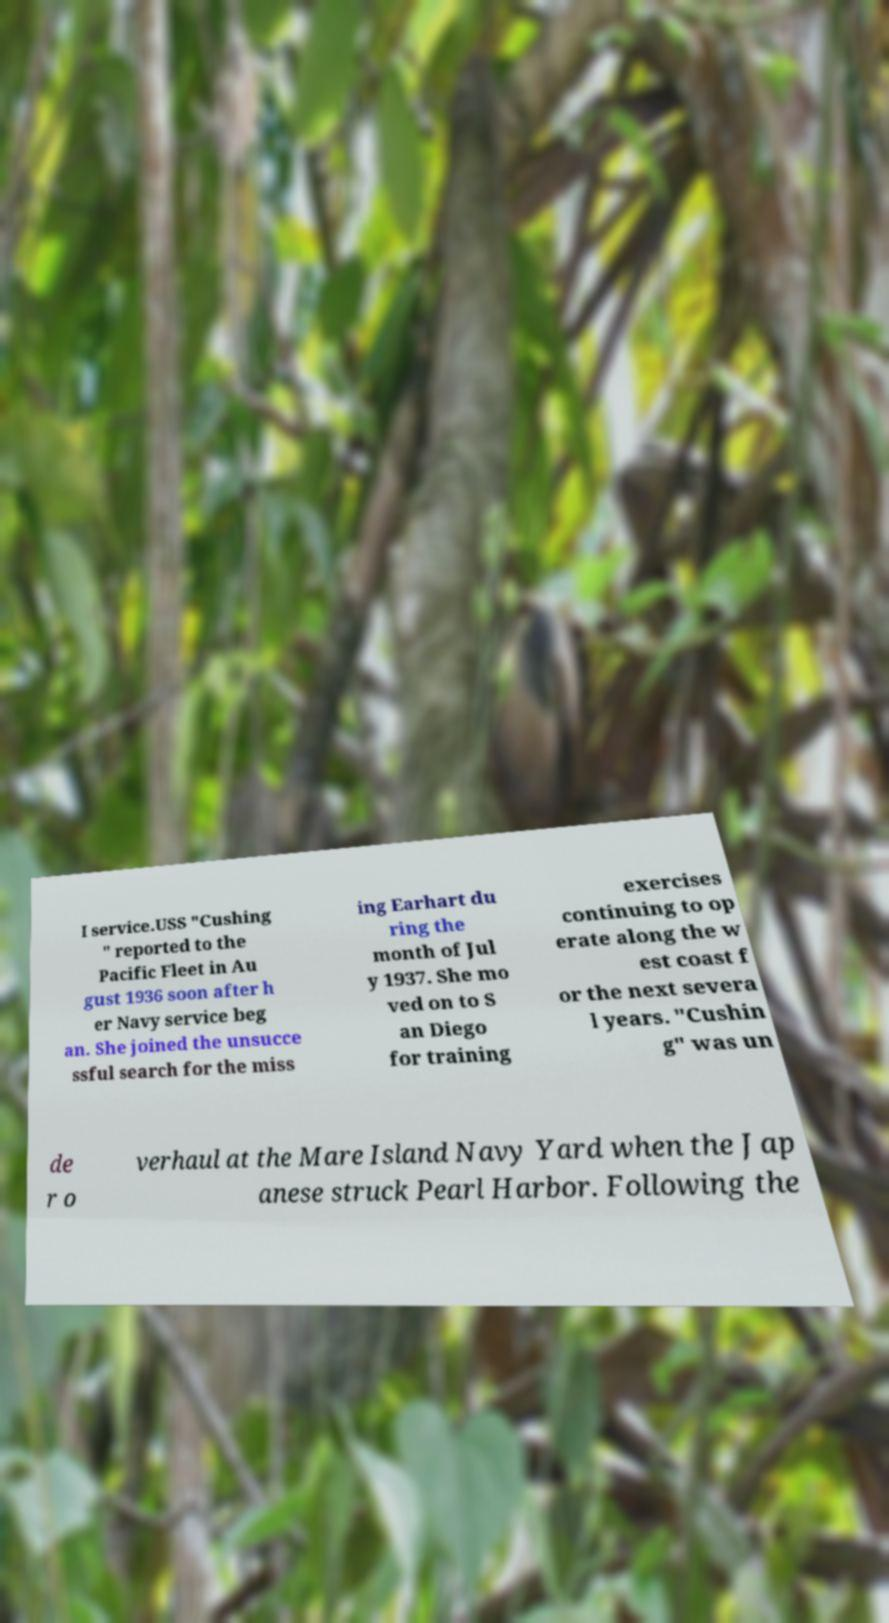Please identify and transcribe the text found in this image. I service.USS "Cushing " reported to the Pacific Fleet in Au gust 1936 soon after h er Navy service beg an. She joined the unsucce ssful search for the miss ing Earhart du ring the month of Jul y 1937. She mo ved on to S an Diego for training exercises continuing to op erate along the w est coast f or the next severa l years. "Cushin g" was un de r o verhaul at the Mare Island Navy Yard when the Jap anese struck Pearl Harbor. Following the 